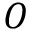<formula> <loc_0><loc_0><loc_500><loc_500>O</formula> 